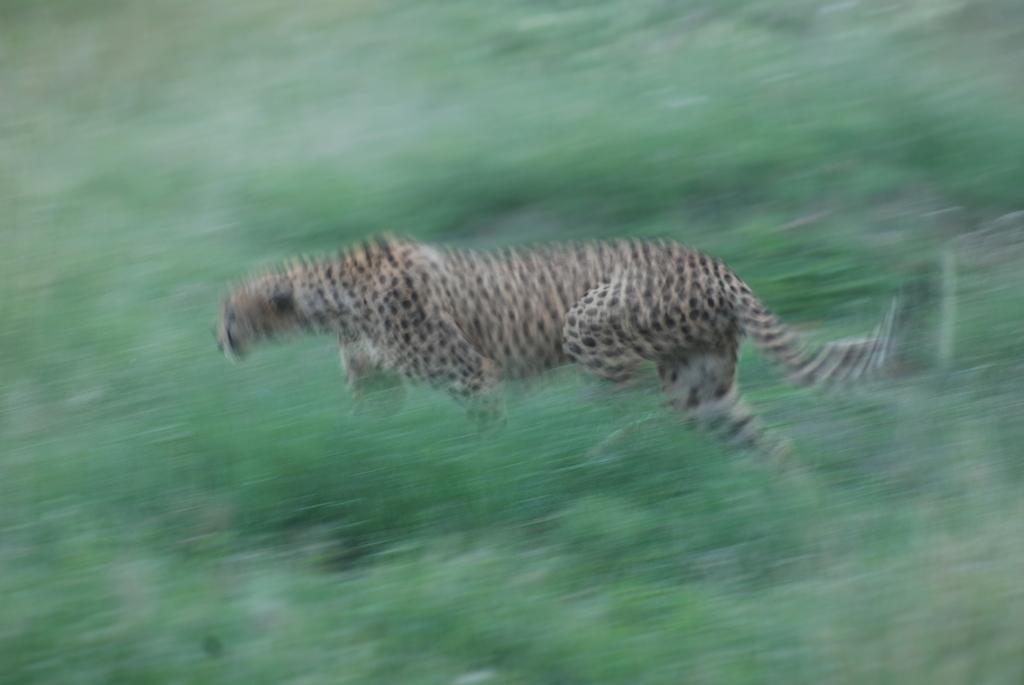Can you describe this image briefly? In this image I can see a cheetah running. This is a blurred image. 